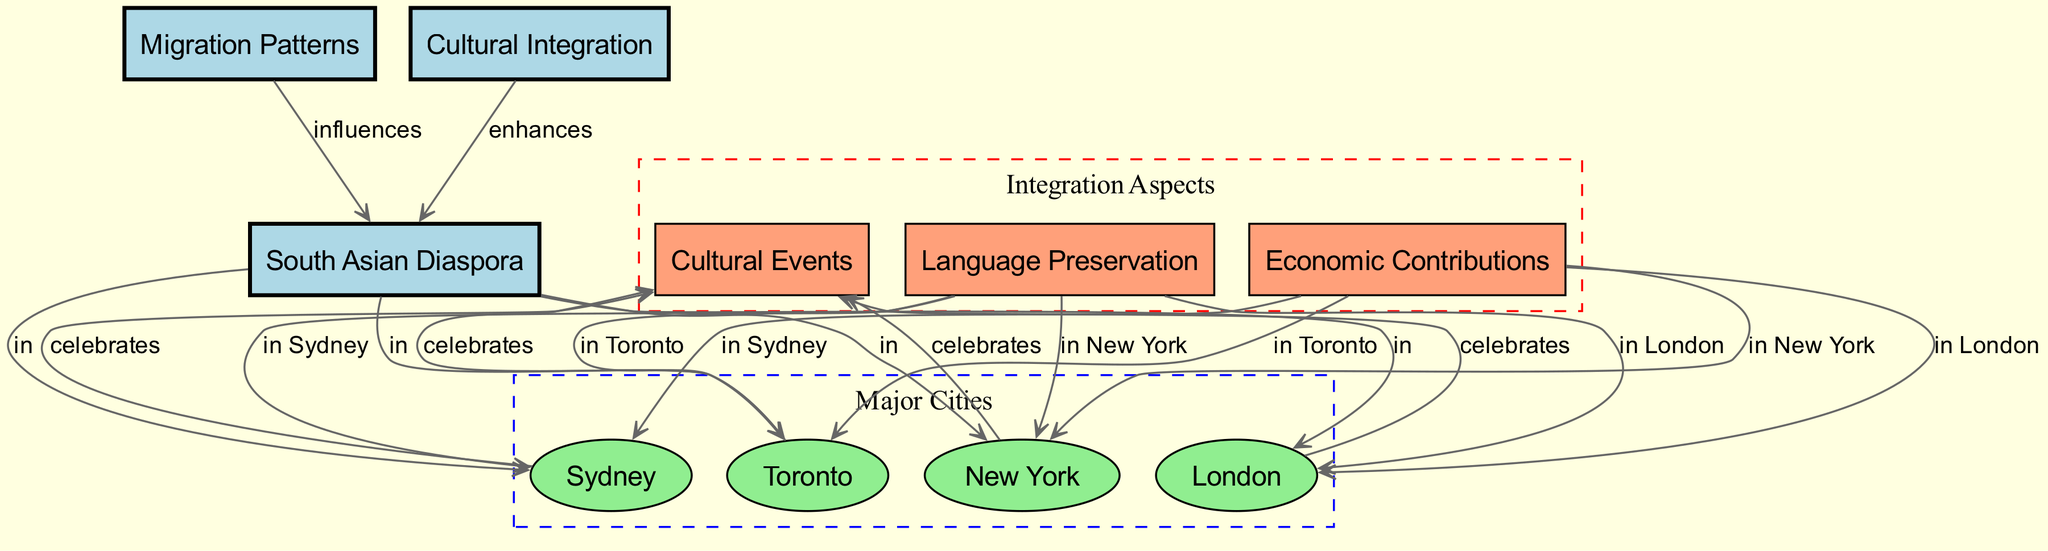What nodes represent major cities in the diagram? The major cities represented in the diagram are linked to the node for the South Asian Diaspora. Specifically, the nodes for London, Toronto, New York, and Sydney are identified as major cities.
Answer: London, Toronto, New York, Sydney How many edges connect the South Asian Diaspora to the major cities? Each of the nodes representing major cities (London, Toronto, New York, and Sydney) has an edge connecting it directly to the South Asian Diaspora node. Therefore, there are four edges in total.
Answer: 4 Which cultural aspect celebrates events in these major cities? The edges connecting London, Toronto, New York, and Sydney to the Cultural Events node indicate that cultural events are celebrated in each of these cities.
Answer: Cultural Events What enhances cultural integration among the South Asian Diaspora? The relationship between the node representing Cultural Integration and the South Asian Diaspora shows that various factors contribute to enhancing cultural integration for the diaspora.
Answer: Culture Which city's diaspora focuses on language preservation? The connection between the Language Preservation node and the city nodes shows that language preservation is significant in each of the major cities with a South Asian diaspora. For a specific city, we would refer to the node that is in the index structure connected via edges.
Answer: London, Toronto, New York, Sydney What influences migration patterns of the South Asian Diaspora? The Migration Patterns node shows a direct influence relationship with the South Asian Diaspora node, indicating that the overall migration trends and patterns notably influence the diaspora's make-up.
Answer: Migration Patterns How is economic contribution evident in the diagram? The economic contributions are represented by edges connecting this node to each of the major cities (London, Toronto, New York, Sydney), indicating that the South Asian diaspora has a notable economic impact in those areas.
Answer: Economic Contributions Which nodes are categorized under integration aspects? The integration aspects can be identified from the edges connecting to Cultural Events, Language Preservation, and Economic Contributions, which are all placed in a subgraph that specifics the characteristics relevant to integration for the diaspora.
Answer: Cultural Events, Language Preservation, Economic Contributions How many nodes are related to the South Asian Diaspora? Counting the nodes connected directly and identifying the South Asian Diaspora node, there are a total of five nodes connected: Migration Patterns, Cultural Integration, London, Toronto, New York, and Sydney.
Answer: 7 